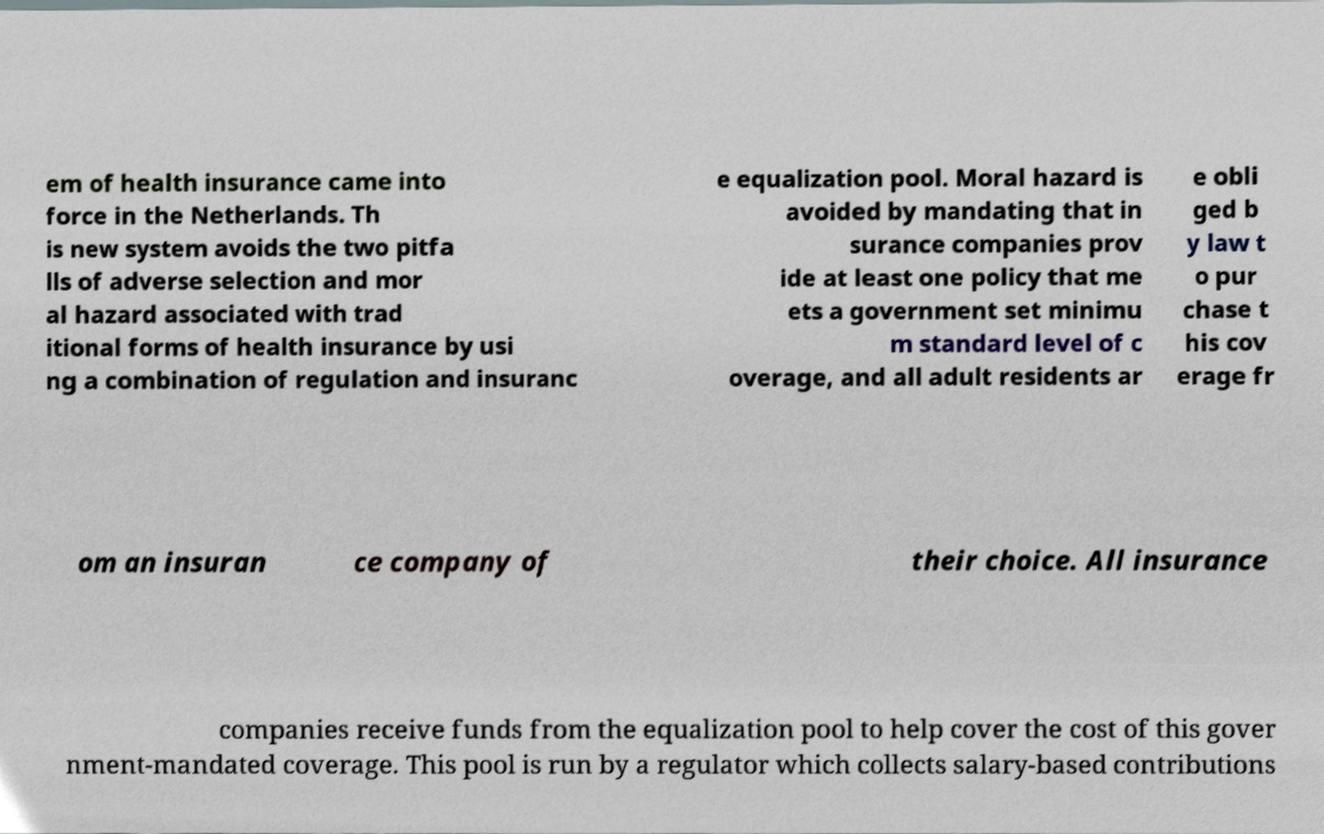For documentation purposes, I need the text within this image transcribed. Could you provide that? em of health insurance came into force in the Netherlands. Th is new system avoids the two pitfa lls of adverse selection and mor al hazard associated with trad itional forms of health insurance by usi ng a combination of regulation and insuranc e equalization pool. Moral hazard is avoided by mandating that in surance companies prov ide at least one policy that me ets a government set minimu m standard level of c overage, and all adult residents ar e obli ged b y law t o pur chase t his cov erage fr om an insuran ce company of their choice. All insurance companies receive funds from the equalization pool to help cover the cost of this gover nment-mandated coverage. This pool is run by a regulator which collects salary-based contributions 